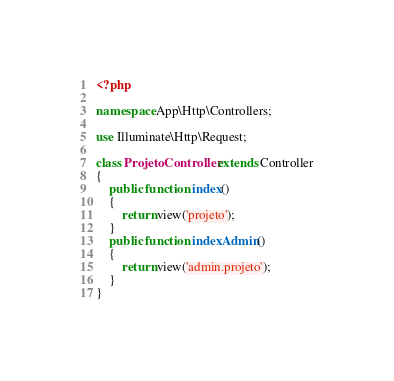<code> <loc_0><loc_0><loc_500><loc_500><_PHP_><?php

namespace App\Http\Controllers;

use Illuminate\Http\Request;

class ProjetoController extends Controller
{
    public function index()
    {
        return view('projeto');
    }
    public function indexAdmin()
    {
        return view('admin.projeto');
    }
}
</code> 